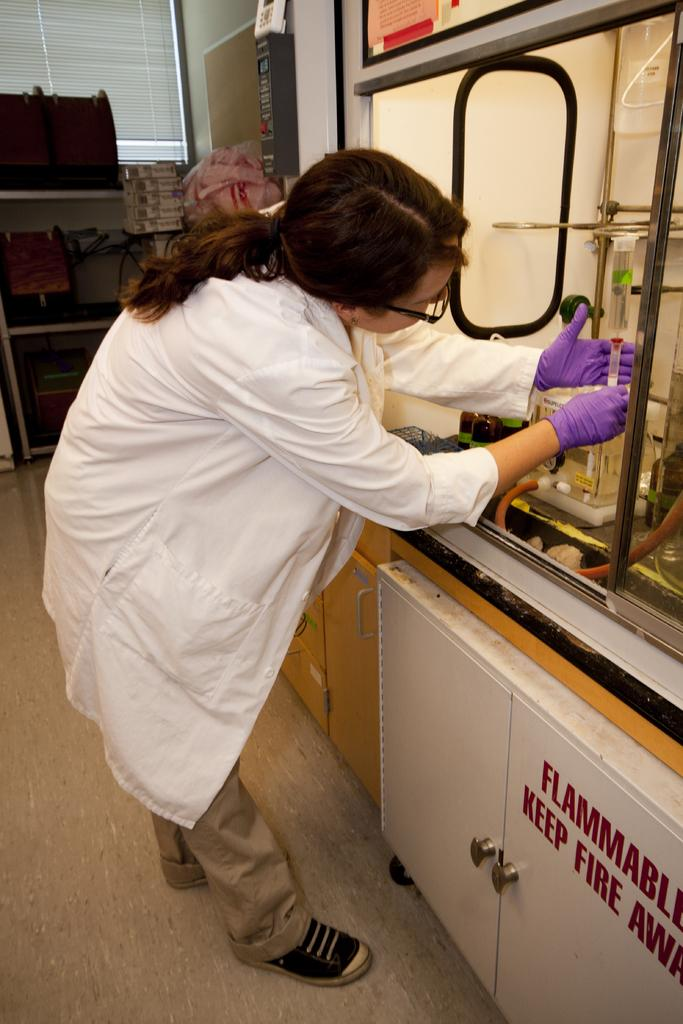<image>
Create a compact narrative representing the image presented. A female in a lab coat working near the sign that says "Flammable Keep Fire Away". 